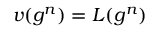Convert formula to latex. <formula><loc_0><loc_0><loc_500><loc_500>v ( g ^ { n } ) = L ( g ^ { n } )</formula> 